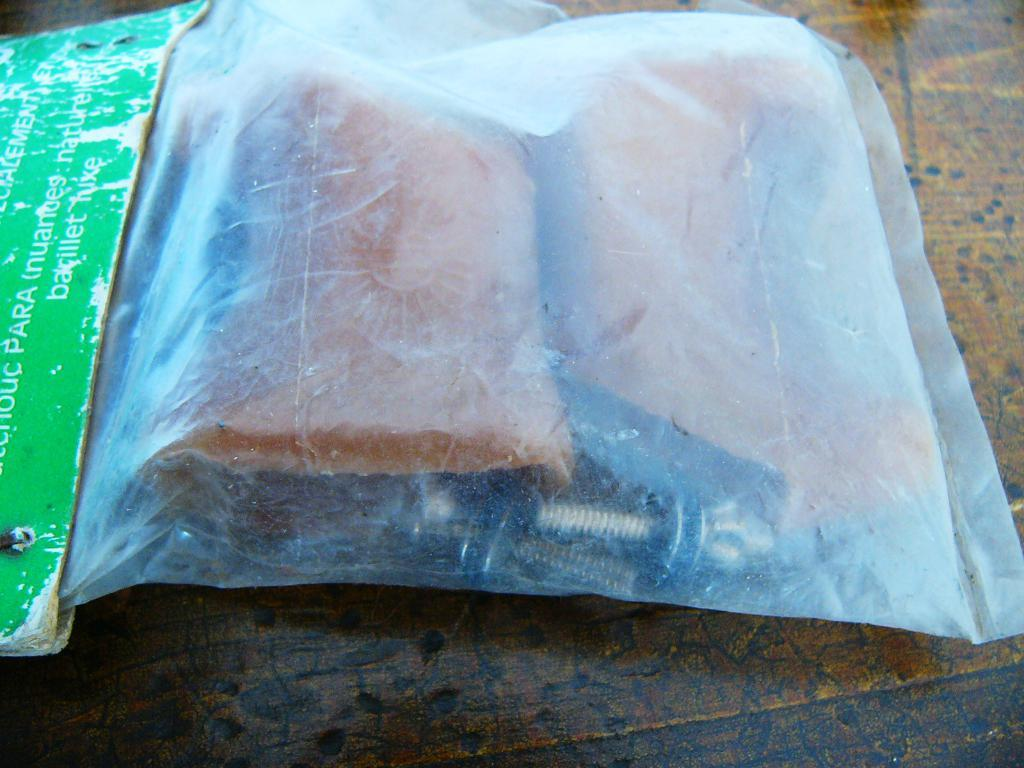What is the packaging material for the objects in the image? The objects are packed in a plastic cover in a plastic cover. What type of surface is the plastic cover resting on? The plastic cover is resting on a wooden surface. What type of collar is visible on the objects in the image? There is no collar present on the objects in the image. 